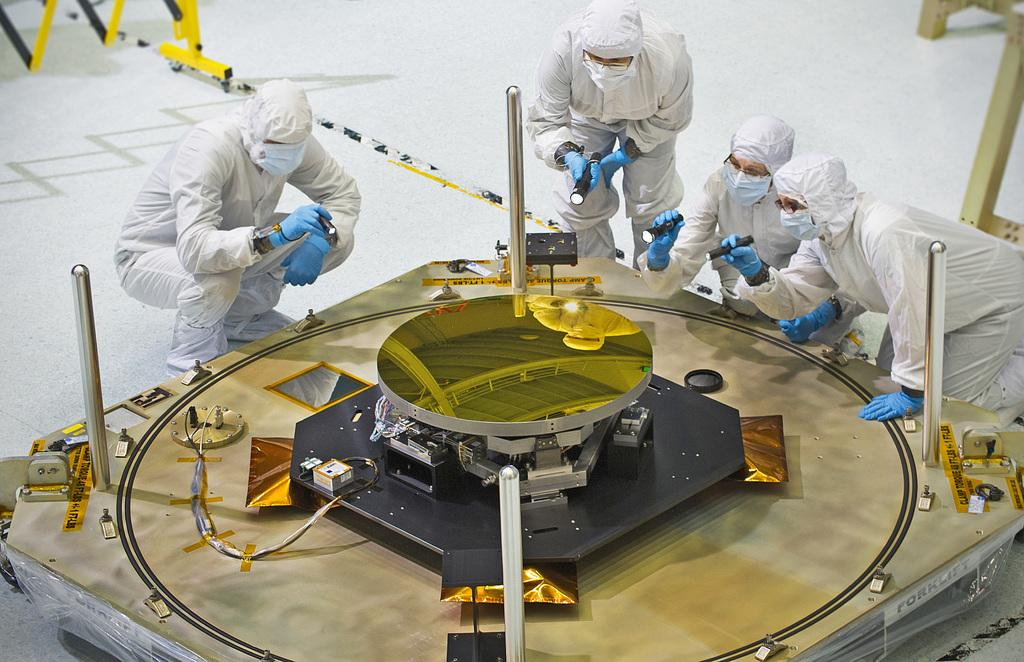What is the main object on the table in the image? A machine is placed on the table in the image. What are the people in the image doing? The people in the image are sitting and watching. Can you describe the table in the image? The table is the main surface where the machine is placed. How many jellyfish can be seen swimming in the background of the image? There are no jellyfish present in the image; it features a table with a machine and people sitting and watching. What type of bait is being used by the people in the image? There is no indication of fishing or bait in the image; it shows a table with a machine and people sitting and watching. 